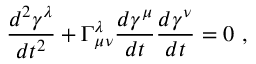Convert formula to latex. <formula><loc_0><loc_0><loc_500><loc_500>{ \frac { d ^ { 2 } \gamma ^ { \lambda } } { d t ^ { 2 } } } + \Gamma _ { \mu \nu } ^ { \lambda } { \frac { d \gamma ^ { \mu } } { d t } } { \frac { d \gamma ^ { \nu } } { d t } } = 0 \ ,</formula> 